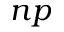Convert formula to latex. <formula><loc_0><loc_0><loc_500><loc_500>n p</formula> 